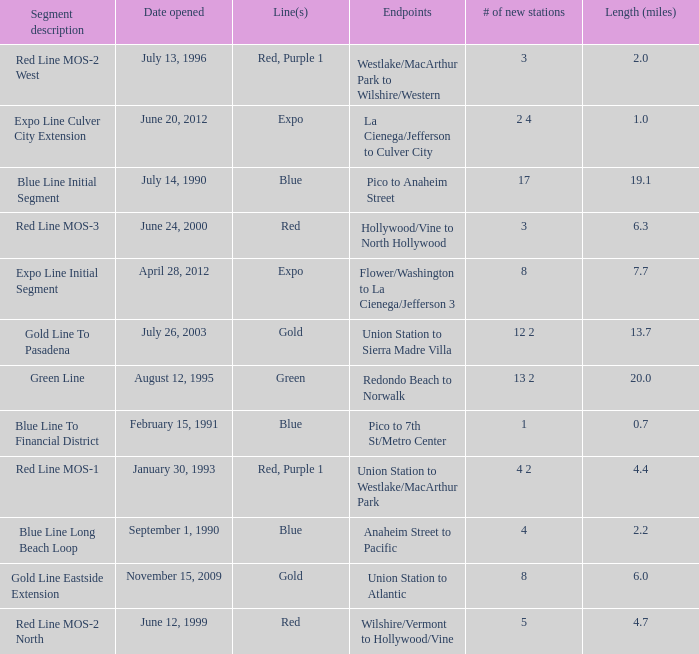What is the length  (miles) when pico to 7th st/metro center are the endpoints? 0.7. 